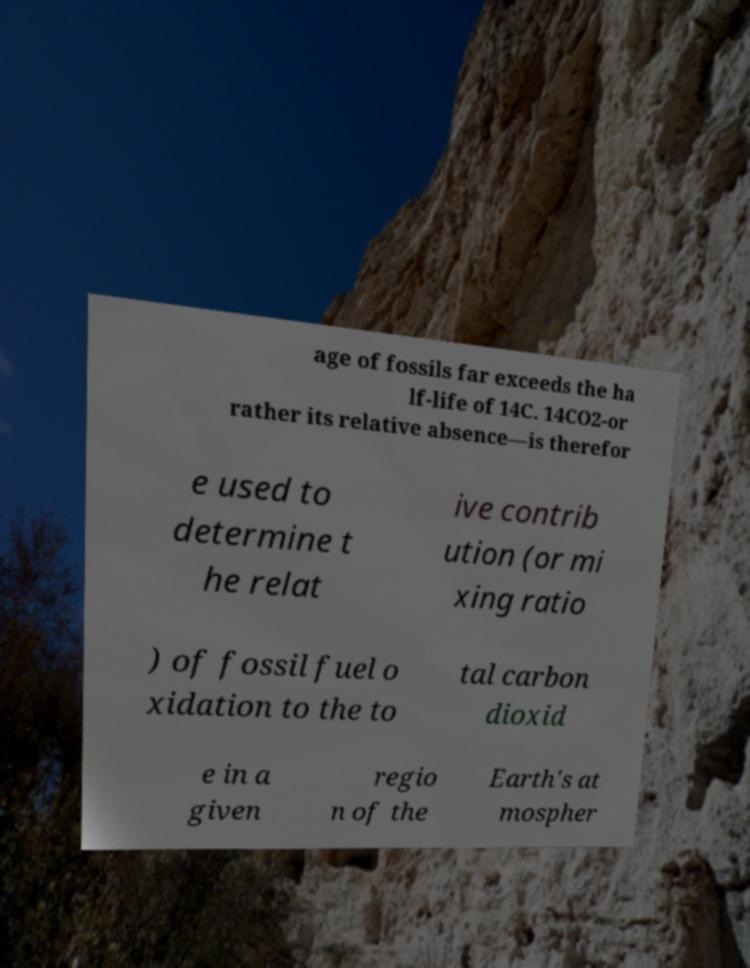Could you extract and type out the text from this image? age of fossils far exceeds the ha lf-life of 14C. 14CO2-or rather its relative absence—is therefor e used to determine t he relat ive contrib ution (or mi xing ratio ) of fossil fuel o xidation to the to tal carbon dioxid e in a given regio n of the Earth's at mospher 